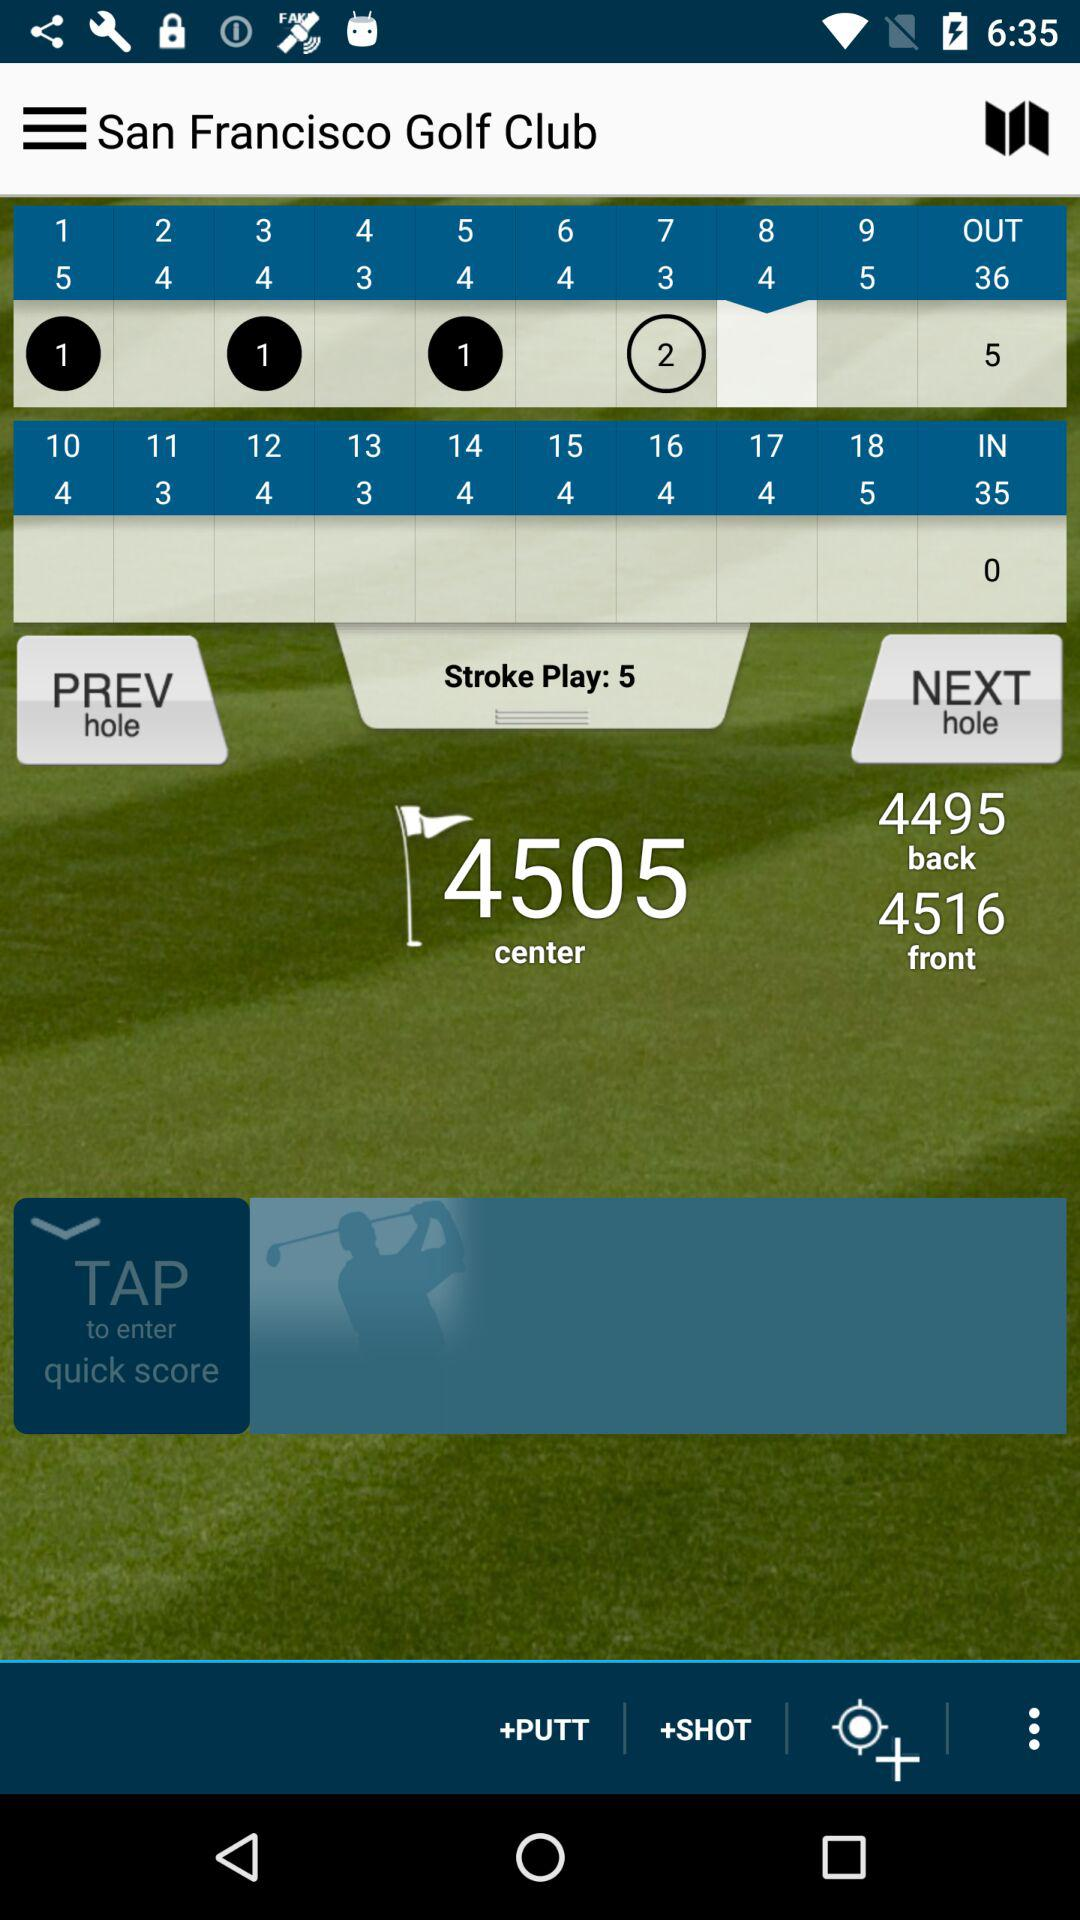What is the score of "OUT"? The score of "OUT" is 5. 